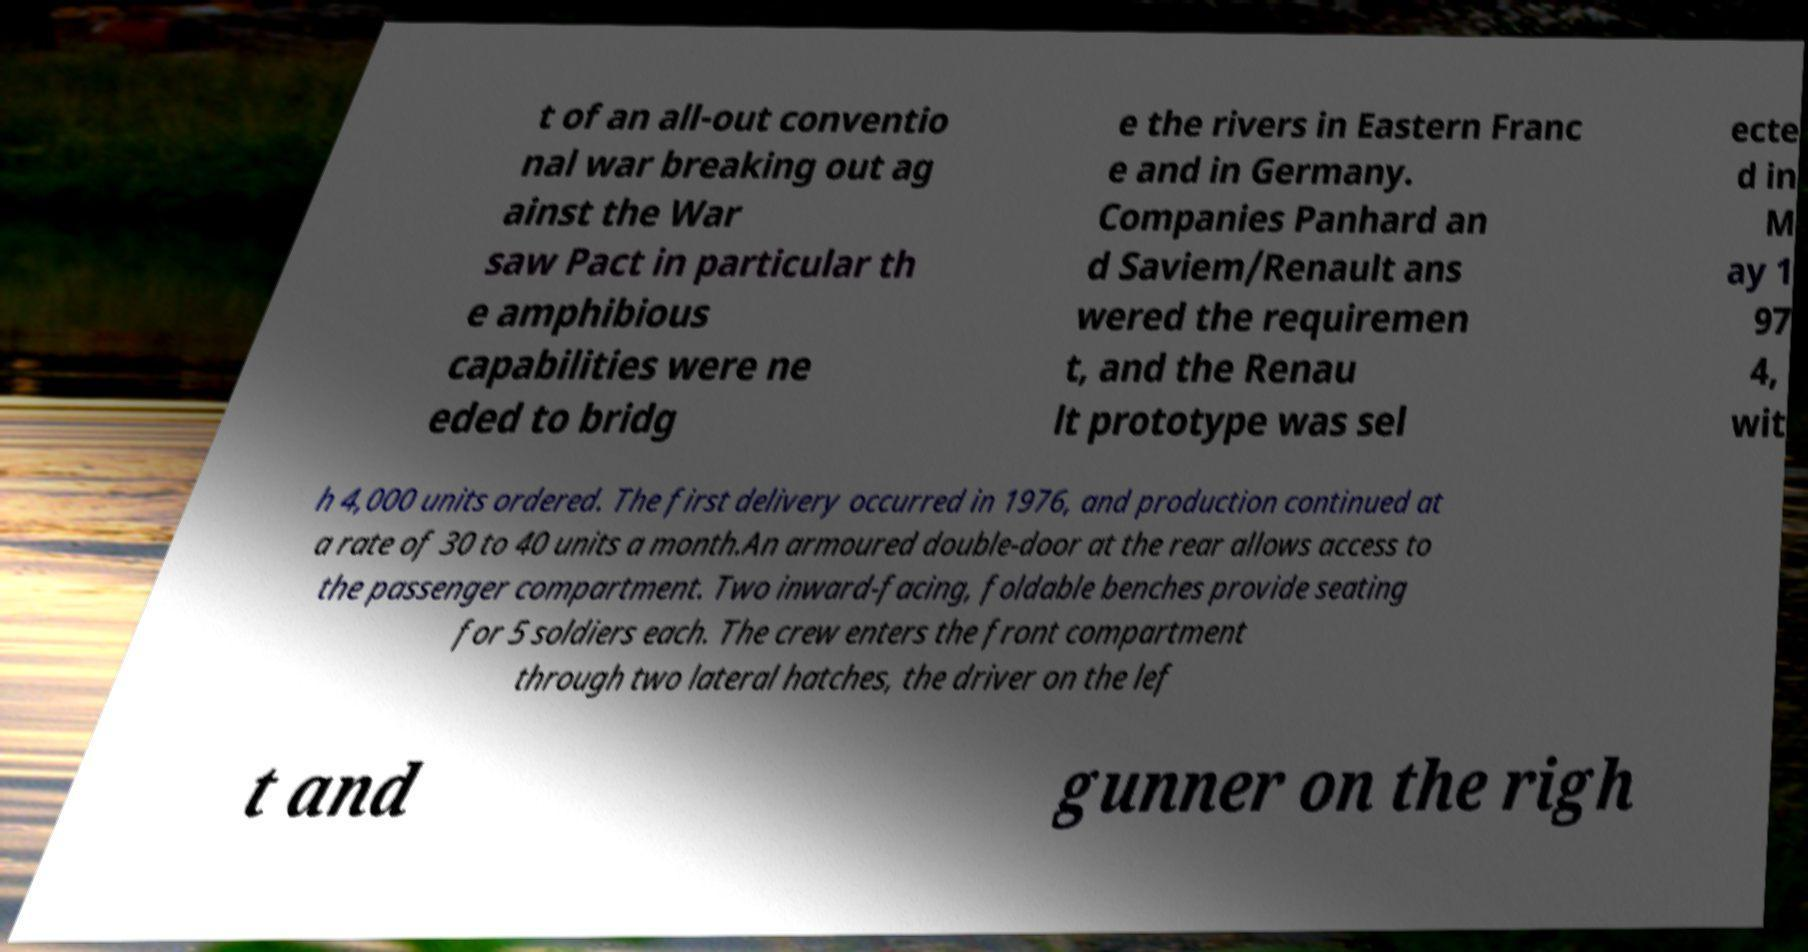I need the written content from this picture converted into text. Can you do that? t of an all-out conventio nal war breaking out ag ainst the War saw Pact in particular th e amphibious capabilities were ne eded to bridg e the rivers in Eastern Franc e and in Germany. Companies Panhard an d Saviem/Renault ans wered the requiremen t, and the Renau lt prototype was sel ecte d in M ay 1 97 4, wit h 4,000 units ordered. The first delivery occurred in 1976, and production continued at a rate of 30 to 40 units a month.An armoured double-door at the rear allows access to the passenger compartment. Two inward-facing, foldable benches provide seating for 5 soldiers each. The crew enters the front compartment through two lateral hatches, the driver on the lef t and gunner on the righ 